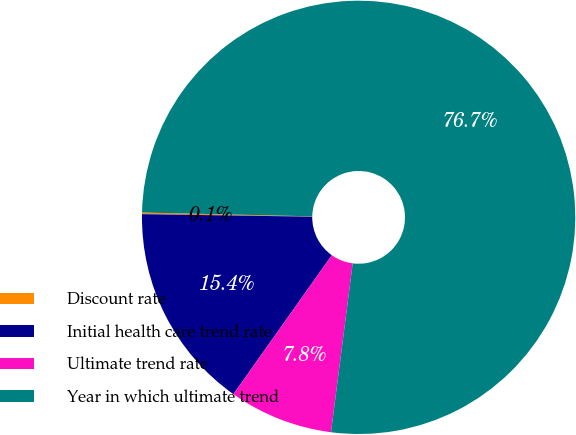Convert chart to OTSL. <chart><loc_0><loc_0><loc_500><loc_500><pie_chart><fcel>Discount rate<fcel>Initial health care trend rate<fcel>Ultimate trend rate<fcel>Year in which ultimate trend<nl><fcel>0.12%<fcel>15.43%<fcel>7.77%<fcel>76.68%<nl></chart> 